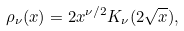Convert formula to latex. <formula><loc_0><loc_0><loc_500><loc_500>\rho _ { \nu } ( x ) = 2 x ^ { \nu / 2 } K _ { \nu } ( 2 \sqrt { x } ) ,</formula> 